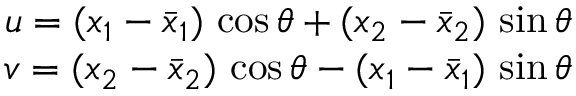Convert formula to latex. <formula><loc_0><loc_0><loc_500><loc_500>\begin{array} { r } { u = ( x _ { 1 } - \bar { x } _ { 1 } ) \, \cos \theta + ( x _ { 2 } - \bar { x } _ { 2 } ) \, \sin \theta } \\ { v = ( x _ { 2 } - \bar { x } _ { 2 } ) \, \cos \theta - ( x _ { 1 } - \bar { x } _ { 1 } ) \, \sin \theta } \end{array}</formula> 